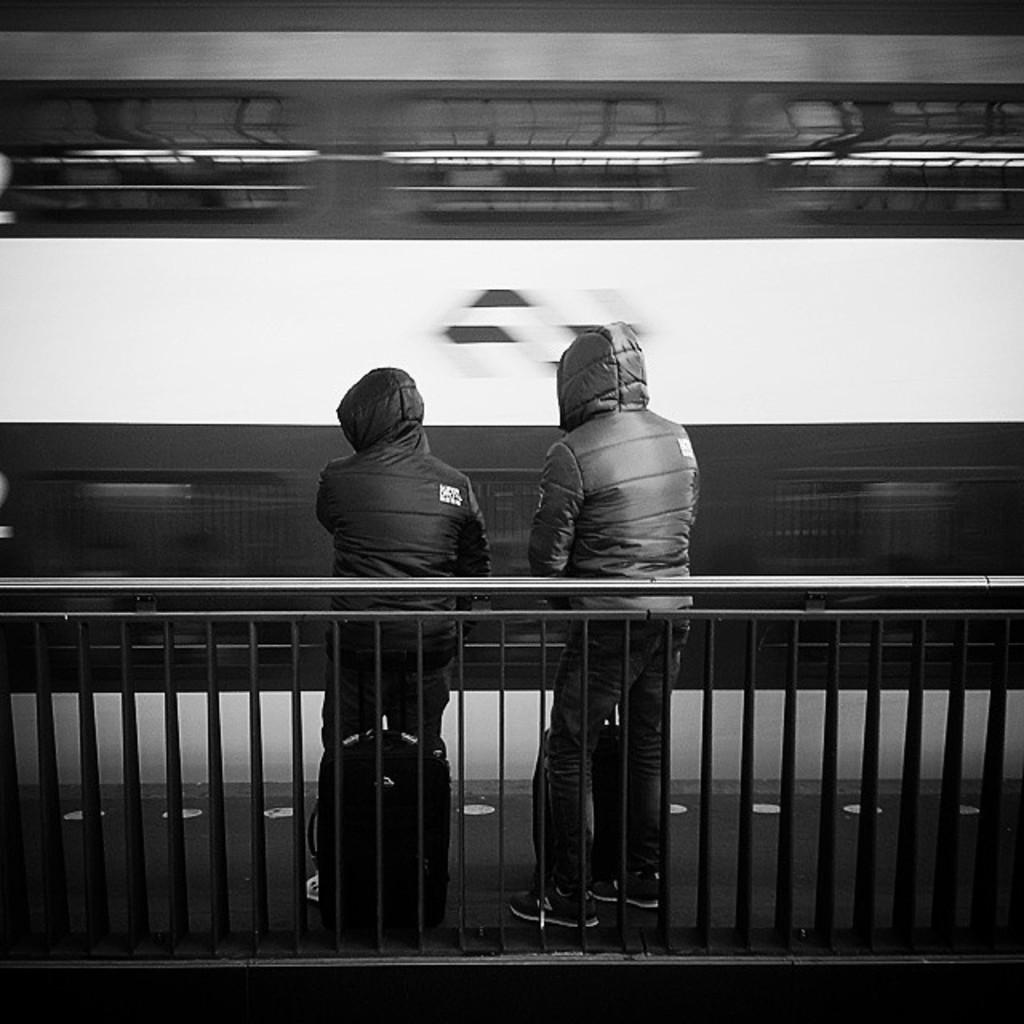What can be seen in the image regarding the persons? There are persons standing in front of the fence. Can you describe the position of the backpack in the image? A backpack is kept on the floor. Where can the icicle be found in the image? There is no icicle present in the image. What type of fold is visible in the image? There is no fold visible in the image. 